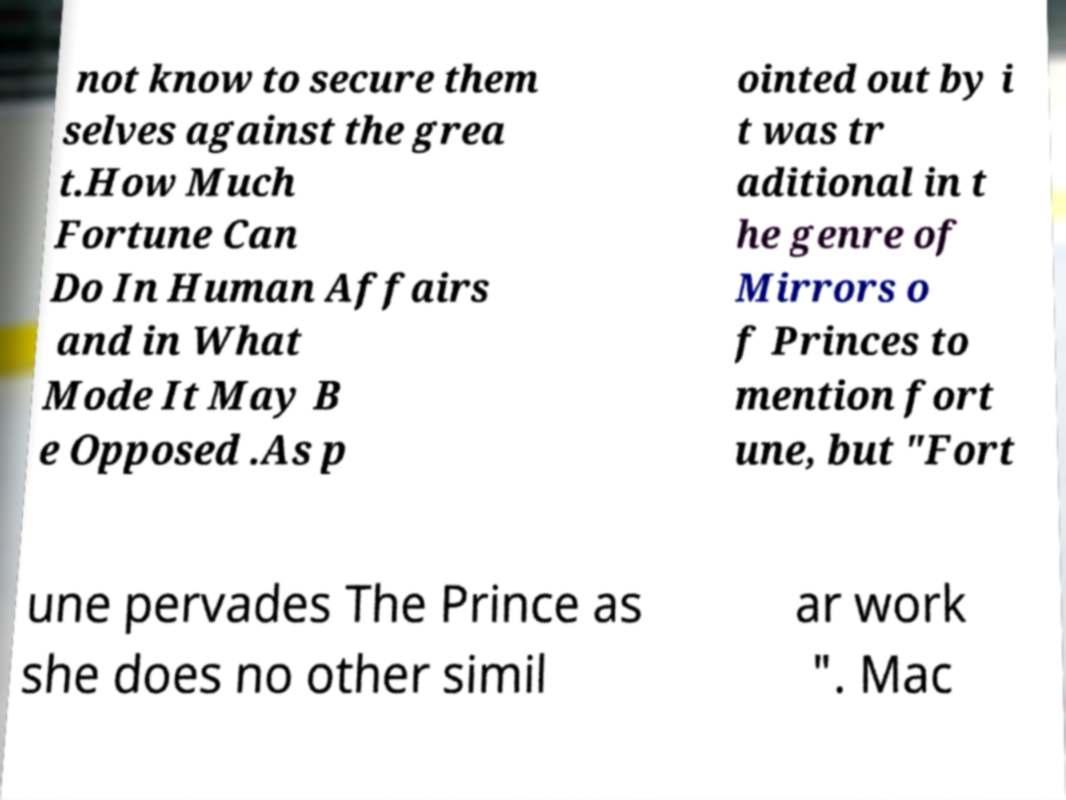Please read and relay the text visible in this image. What does it say? not know to secure them selves against the grea t.How Much Fortune Can Do In Human Affairs and in What Mode It May B e Opposed .As p ointed out by i t was tr aditional in t he genre of Mirrors o f Princes to mention fort une, but "Fort une pervades The Prince as she does no other simil ar work ". Mac 